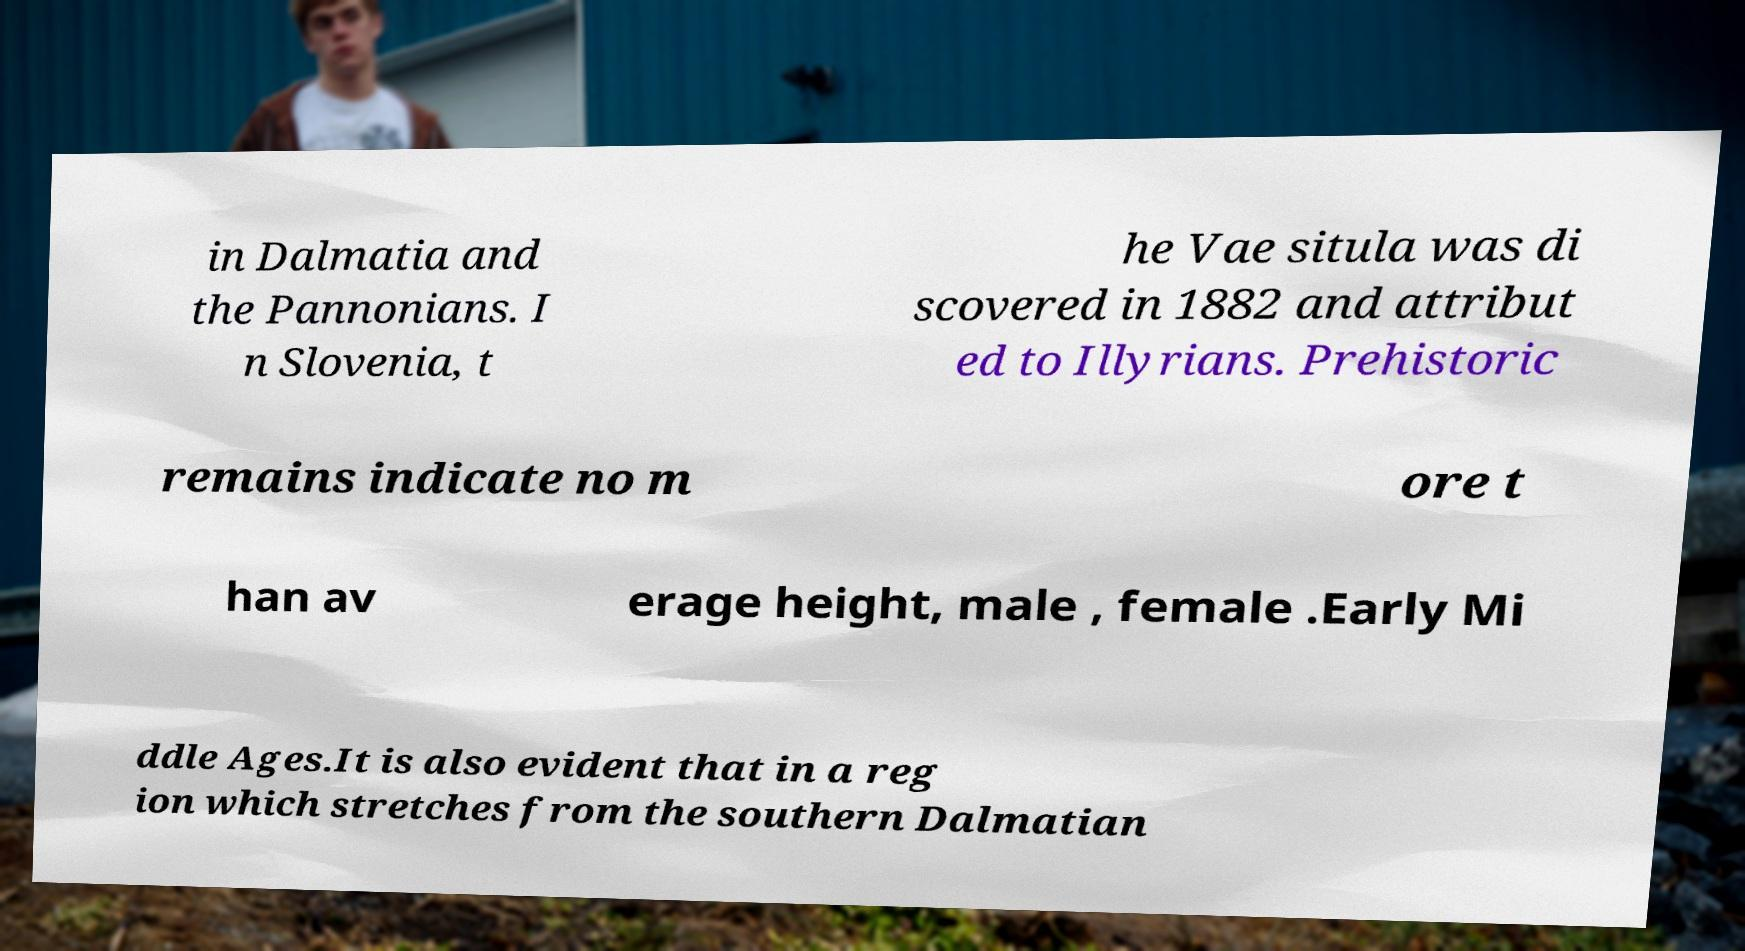What messages or text are displayed in this image? I need them in a readable, typed format. in Dalmatia and the Pannonians. I n Slovenia, t he Vae situla was di scovered in 1882 and attribut ed to Illyrians. Prehistoric remains indicate no m ore t han av erage height, male , female .Early Mi ddle Ages.It is also evident that in a reg ion which stretches from the southern Dalmatian 